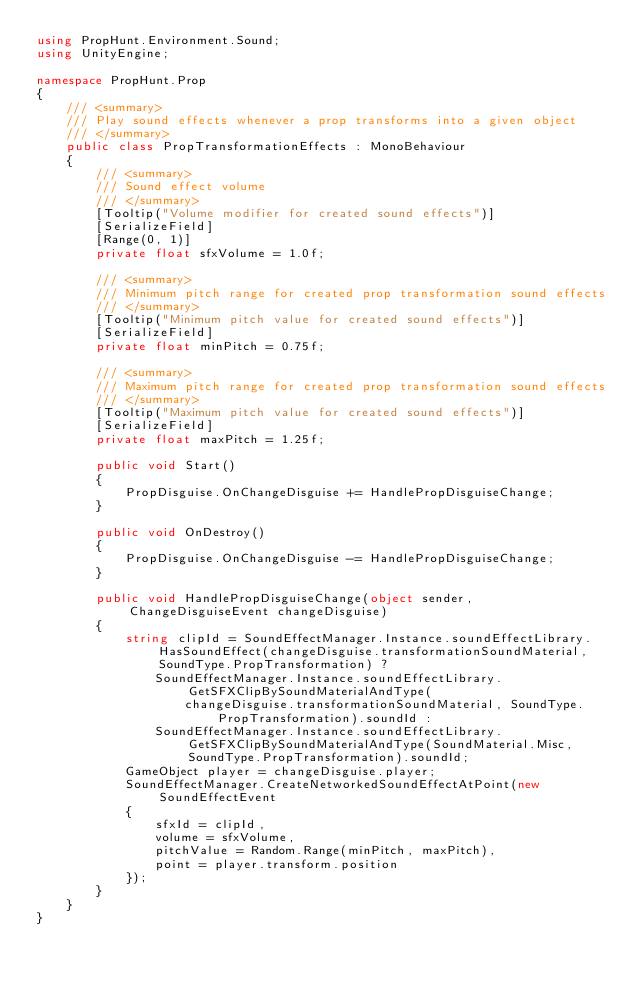Convert code to text. <code><loc_0><loc_0><loc_500><loc_500><_C#_>using PropHunt.Environment.Sound;
using UnityEngine;

namespace PropHunt.Prop
{
    /// <summary>
    /// Play sound effects whenever a prop transforms into a given object
    /// </summary>
    public class PropTransformationEffects : MonoBehaviour
    {
        /// <summary>
        /// Sound effect volume
        /// </summary>
        [Tooltip("Volume modifier for created sound effects")]
        [SerializeField]
        [Range(0, 1)]
        private float sfxVolume = 1.0f;

        /// <summary>
        /// Minimum pitch range for created prop transformation sound effects
        /// </summary>
        [Tooltip("Minimum pitch value for created sound effects")]
        [SerializeField]
        private float minPitch = 0.75f;

        /// <summary>
        /// Maximum pitch range for created prop transformation sound effects
        /// </summary>
        [Tooltip("Maximum pitch value for created sound effects")]
        [SerializeField]
        private float maxPitch = 1.25f;

        public void Start()
        {
            PropDisguise.OnChangeDisguise += HandlePropDisguiseChange;
        }

        public void OnDestroy()
        {
            PropDisguise.OnChangeDisguise -= HandlePropDisguiseChange;
        }

        public void HandlePropDisguiseChange(object sender, ChangeDisguiseEvent changeDisguise)
        {
            string clipId = SoundEffectManager.Instance.soundEffectLibrary.HasSoundEffect(changeDisguise.transformationSoundMaterial, SoundType.PropTransformation) ?
                SoundEffectManager.Instance.soundEffectLibrary.GetSFXClipBySoundMaterialAndType(
                    changeDisguise.transformationSoundMaterial, SoundType.PropTransformation).soundId :
                SoundEffectManager.Instance.soundEffectLibrary.GetSFXClipBySoundMaterialAndType(SoundMaterial.Misc, SoundType.PropTransformation).soundId;
            GameObject player = changeDisguise.player;
            SoundEffectManager.CreateNetworkedSoundEffectAtPoint(new SoundEffectEvent
            {
                sfxId = clipId,
                volume = sfxVolume,
                pitchValue = Random.Range(minPitch, maxPitch),
                point = player.transform.position
            });
        }
    }
}</code> 